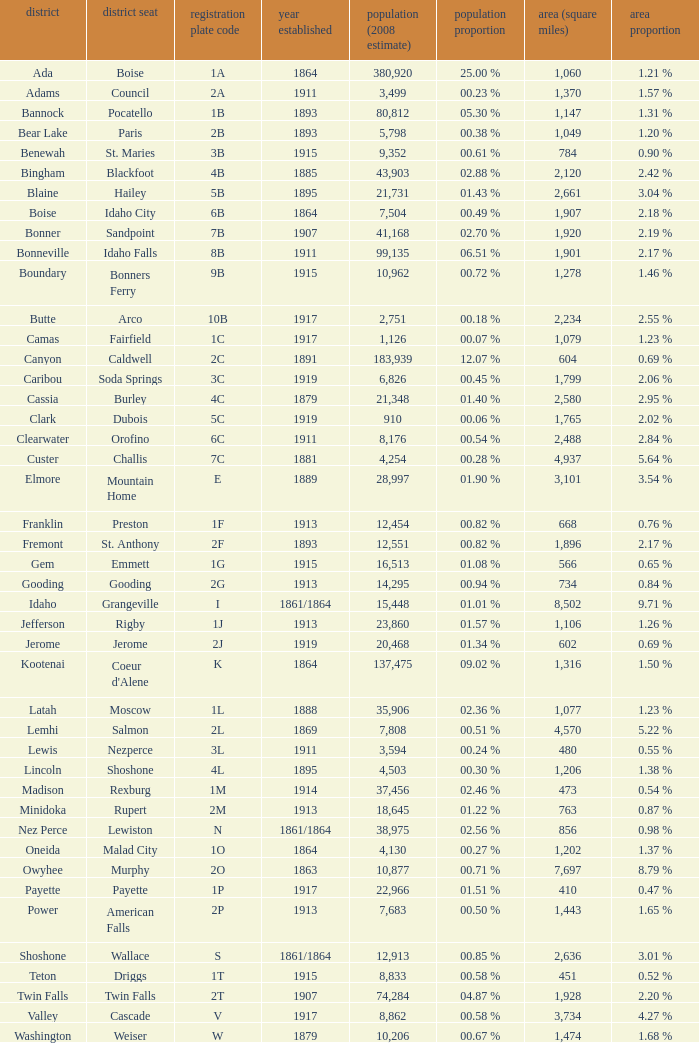Can you give me this table as a dict? {'header': ['district', 'district seat', 'registration plate code', 'year established', 'population (2008 estimate)', 'population proportion', 'area (square miles)', 'area proportion'], 'rows': [['Ada', 'Boise', '1A', '1864', '380,920', '25.00 %', '1,060', '1.21 %'], ['Adams', 'Council', '2A', '1911', '3,499', '00.23 %', '1,370', '1.57 %'], ['Bannock', 'Pocatello', '1B', '1893', '80,812', '05.30 %', '1,147', '1.31 %'], ['Bear Lake', 'Paris', '2B', '1893', '5,798', '00.38 %', '1,049', '1.20 %'], ['Benewah', 'St. Maries', '3B', '1915', '9,352', '00.61 %', '784', '0.90 %'], ['Bingham', 'Blackfoot', '4B', '1885', '43,903', '02.88 %', '2,120', '2.42 %'], ['Blaine', 'Hailey', '5B', '1895', '21,731', '01.43 %', '2,661', '3.04 %'], ['Boise', 'Idaho City', '6B', '1864', '7,504', '00.49 %', '1,907', '2.18 %'], ['Bonner', 'Sandpoint', '7B', '1907', '41,168', '02.70 %', '1,920', '2.19 %'], ['Bonneville', 'Idaho Falls', '8B', '1911', '99,135', '06.51 %', '1,901', '2.17 %'], ['Boundary', 'Bonners Ferry', '9B', '1915', '10,962', '00.72 %', '1,278', '1.46 %'], ['Butte', 'Arco', '10B', '1917', '2,751', '00.18 %', '2,234', '2.55 %'], ['Camas', 'Fairfield', '1C', '1917', '1,126', '00.07 %', '1,079', '1.23 %'], ['Canyon', 'Caldwell', '2C', '1891', '183,939', '12.07 %', '604', '0.69 %'], ['Caribou', 'Soda Springs', '3C', '1919', '6,826', '00.45 %', '1,799', '2.06 %'], ['Cassia', 'Burley', '4C', '1879', '21,348', '01.40 %', '2,580', '2.95 %'], ['Clark', 'Dubois', '5C', '1919', '910', '00.06 %', '1,765', '2.02 %'], ['Clearwater', 'Orofino', '6C', '1911', '8,176', '00.54 %', '2,488', '2.84 %'], ['Custer', 'Challis', '7C', '1881', '4,254', '00.28 %', '4,937', '5.64 %'], ['Elmore', 'Mountain Home', 'E', '1889', '28,997', '01.90 %', '3,101', '3.54 %'], ['Franklin', 'Preston', '1F', '1913', '12,454', '00.82 %', '668', '0.76 %'], ['Fremont', 'St. Anthony', '2F', '1893', '12,551', '00.82 %', '1,896', '2.17 %'], ['Gem', 'Emmett', '1G', '1915', '16,513', '01.08 %', '566', '0.65 %'], ['Gooding', 'Gooding', '2G', '1913', '14,295', '00.94 %', '734', '0.84 %'], ['Idaho', 'Grangeville', 'I', '1861/1864', '15,448', '01.01 %', '8,502', '9.71 %'], ['Jefferson', 'Rigby', '1J', '1913', '23,860', '01.57 %', '1,106', '1.26 %'], ['Jerome', 'Jerome', '2J', '1919', '20,468', '01.34 %', '602', '0.69 %'], ['Kootenai', "Coeur d'Alene", 'K', '1864', '137,475', '09.02 %', '1,316', '1.50 %'], ['Latah', 'Moscow', '1L', '1888', '35,906', '02.36 %', '1,077', '1.23 %'], ['Lemhi', 'Salmon', '2L', '1869', '7,808', '00.51 %', '4,570', '5.22 %'], ['Lewis', 'Nezperce', '3L', '1911', '3,594', '00.24 %', '480', '0.55 %'], ['Lincoln', 'Shoshone', '4L', '1895', '4,503', '00.30 %', '1,206', '1.38 %'], ['Madison', 'Rexburg', '1M', '1914', '37,456', '02.46 %', '473', '0.54 %'], ['Minidoka', 'Rupert', '2M', '1913', '18,645', '01.22 %', '763', '0.87 %'], ['Nez Perce', 'Lewiston', 'N', '1861/1864', '38,975', '02.56 %', '856', '0.98 %'], ['Oneida', 'Malad City', '1O', '1864', '4,130', '00.27 %', '1,202', '1.37 %'], ['Owyhee', 'Murphy', '2O', '1863', '10,877', '00.71 %', '7,697', '8.79 %'], ['Payette', 'Payette', '1P', '1917', '22,966', '01.51 %', '410', '0.47 %'], ['Power', 'American Falls', '2P', '1913', '7,683', '00.50 %', '1,443', '1.65 %'], ['Shoshone', 'Wallace', 'S', '1861/1864', '12,913', '00.85 %', '2,636', '3.01 %'], ['Teton', 'Driggs', '1T', '1915', '8,833', '00.58 %', '451', '0.52 %'], ['Twin Falls', 'Twin Falls', '2T', '1907', '74,284', '04.87 %', '1,928', '2.20 %'], ['Valley', 'Cascade', 'V', '1917', '8,862', '00.58 %', '3,734', '4.27 %'], ['Washington', 'Weiser', 'W', '1879', '10,206', '00.67 %', '1,474', '1.68 %']]} What is the country seat for the license plate code 5c? Dubois. 